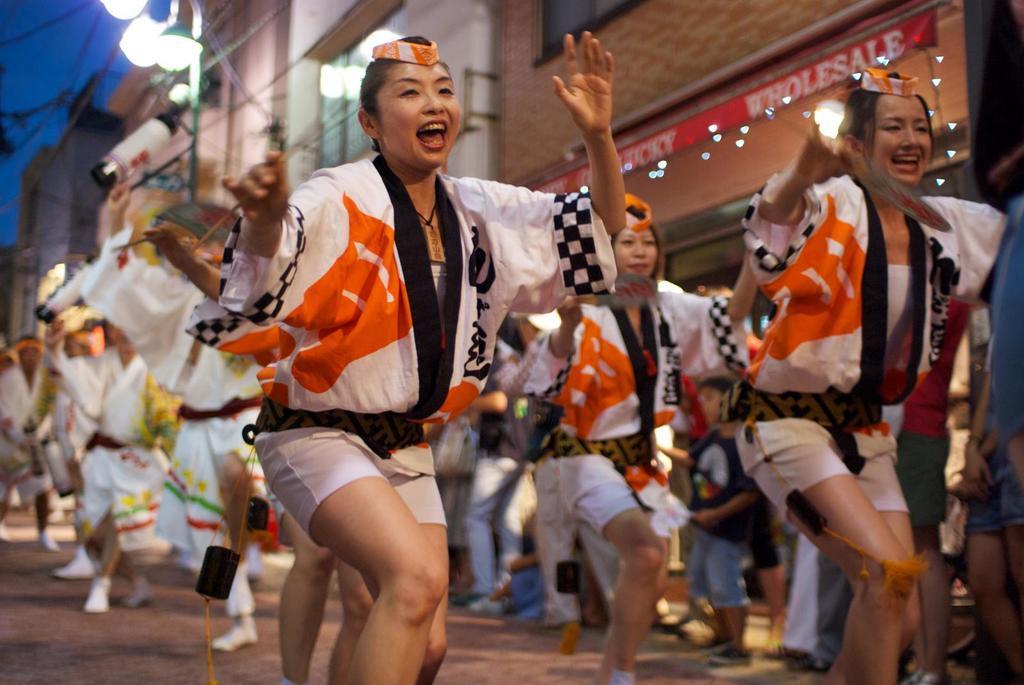Describe this image in one or two sentences. In this image we can see some people and among them few people holding some objects in their hands and it looks like they are dancing. We can see some buildings in the background and there is a street light and we can see the sky at the top. 